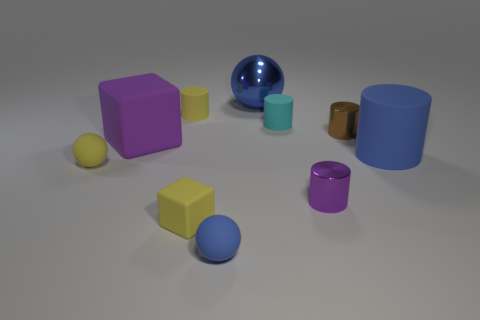Subtract all small yellow spheres. How many spheres are left? 2 Subtract all purple cylinders. How many blue spheres are left? 2 Subtract all yellow blocks. How many blocks are left? 1 Subtract all cubes. How many objects are left? 8 Subtract 0 red spheres. How many objects are left? 10 Subtract all gray balls. Subtract all green cylinders. How many balls are left? 3 Subtract all tiny cyan matte cylinders. Subtract all tiny brown cylinders. How many objects are left? 8 Add 2 tiny yellow things. How many tiny yellow things are left? 5 Add 5 tiny brown cylinders. How many tiny brown cylinders exist? 6 